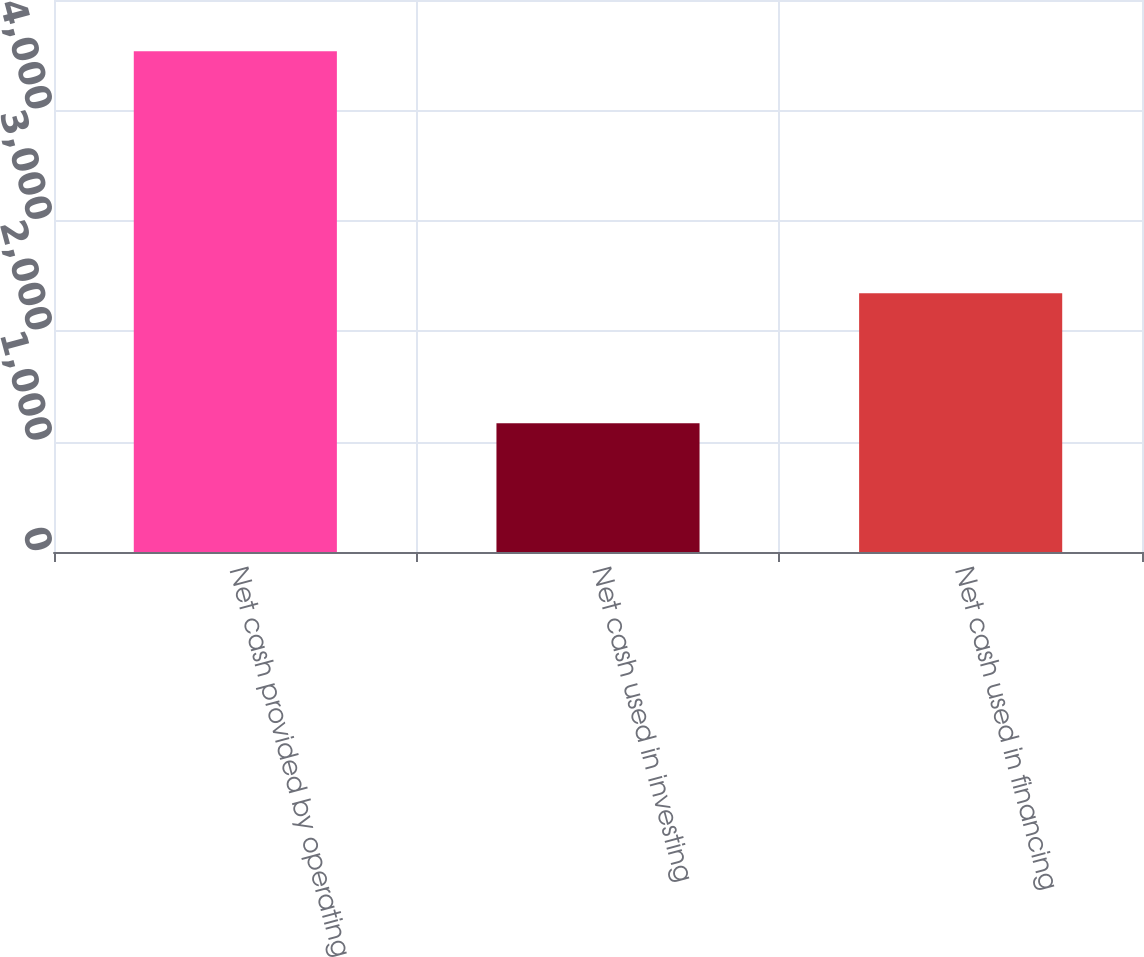Convert chart to OTSL. <chart><loc_0><loc_0><loc_500><loc_500><bar_chart><fcel>Net cash provided by operating<fcel>Net cash used in investing<fcel>Net cash used in financing<nl><fcel>4535<fcel>1167<fcel>2344<nl></chart> 